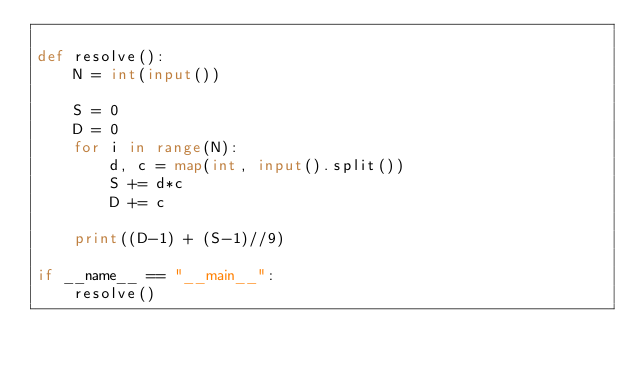Convert code to text. <code><loc_0><loc_0><loc_500><loc_500><_Python_>
def resolve():
    N = int(input())

    S = 0
    D = 0
    for i in range(N):
        d, c = map(int, input().split())
        S += d*c
        D += c

    print((D-1) + (S-1)//9)

if __name__ == "__main__":
    resolve()</code> 